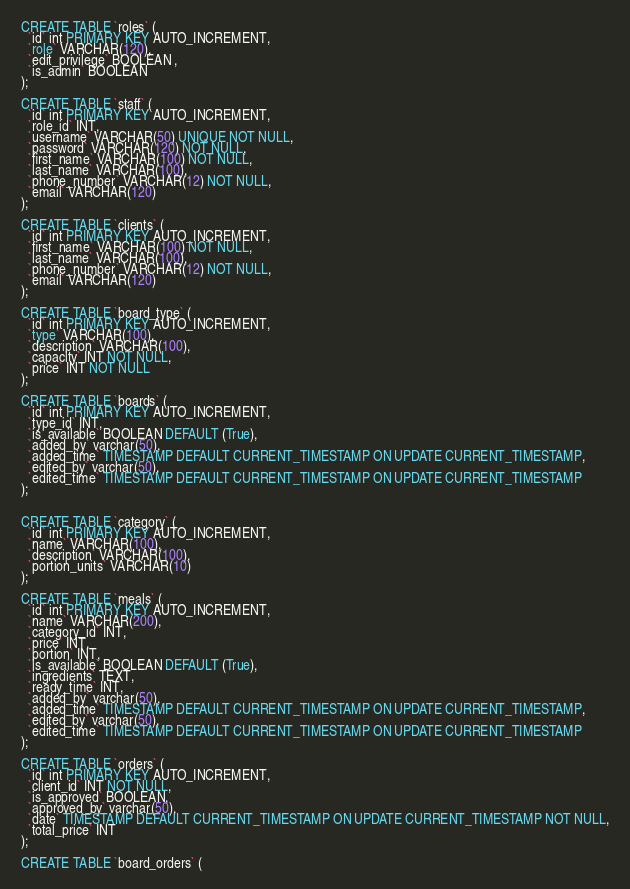Convert code to text. <code><loc_0><loc_0><loc_500><loc_500><_SQL_>CREATE TABLE `roles` (
  `id` int PRIMARY KEY AUTO_INCREMENT,
  `role` VARCHAR(120),
  `edit_privilege` BOOLEAN ,
  `is_admin` BOOLEAN
);

CREATE TABLE `staff` (
  `id` int PRIMARY KEY AUTO_INCREMENT,
  `role_id` INT,
  `username` VARCHAR(50) UNIQUE NOT NULL,
  `password` VARCHAR(120) NOT NULL,
  `first_name` VARCHAR(100) NOT NULL,
  `last_name` VARCHAR(100),
  `phone_number` VARCHAR(12) NOT NULL,
  `email` VARCHAR(120)
);

CREATE TABLE `clients` (
  `id` int PRIMARY KEY AUTO_INCREMENT,
  `first_name` VARCHAR(100) NOT NULL,
  `last_name` VARCHAR(100),
  `phone_number` VARCHAR(12) NOT NULL,
  `email` VARCHAR(120)
);

CREATE TABLE `board_type` (
  `id` int PRIMARY KEY AUTO_INCREMENT,
  `type` VARCHAR(100),
  `description` VARCHAR(100),
  `capacity` INT NOT NULL,
  `price` INT NOT NULL
);

CREATE TABLE `boards` (
  `id` int PRIMARY KEY AUTO_INCREMENT,
  `type_id` INT,
  `is_available` BOOLEAN DEFAULT (True),
  `added_by` varchar(50),
  `added_time` TIMESTAMP DEFAULT CURRENT_TIMESTAMP ON UPDATE CURRENT_TIMESTAMP,
  `edited_by` varchar(50),
  `edited_time` TIMESTAMP DEFAULT CURRENT_TIMESTAMP ON UPDATE CURRENT_TIMESTAMP
);


CREATE TABLE `category` (
  `id` int PRIMARY KEY AUTO_INCREMENT,
  `name` VARCHAR(100),
  `description` VARCHAR(100),
  `portion_units` VARCHAR(10)
);

CREATE TABLE `meals` (
  `id` int PRIMARY KEY AUTO_INCREMENT,
  `name` VARCHAR(200),
  `category_id` INT,
  `price` INT,
  `portion` INT,
  `is_available` BOOLEAN DEFAULT (True),
  `ingredients` TEXT,
  `ready_time` INT,
  `added_by` varchar(50),
  `added_time` TIMESTAMP DEFAULT CURRENT_TIMESTAMP ON UPDATE CURRENT_TIMESTAMP,
  `edited_by` varchar(50),
  `edited_time` TIMESTAMP DEFAULT CURRENT_TIMESTAMP ON UPDATE CURRENT_TIMESTAMP
);

CREATE TABLE `orders` (
  `id` int PRIMARY KEY AUTO_INCREMENT,
  `client_id` INT NOT NULL,
  `is_approved` BOOLEAN,
  `approved_by` varchar(50),
  `date` TIMESTAMP DEFAULT CURRENT_TIMESTAMP ON UPDATE CURRENT_TIMESTAMP NOT NULL,
  `total_price` INT
);

CREATE TABLE `board_orders` (</code> 